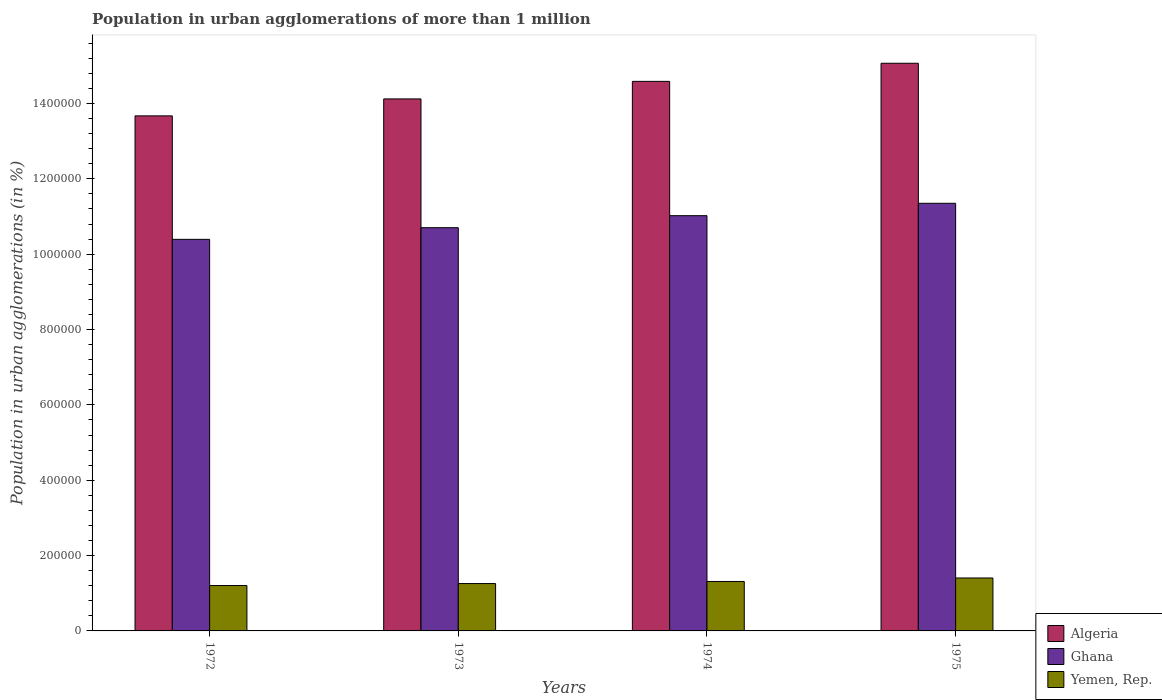How many different coloured bars are there?
Provide a short and direct response. 3. How many groups of bars are there?
Ensure brevity in your answer.  4. Are the number of bars per tick equal to the number of legend labels?
Your answer should be very brief. Yes. How many bars are there on the 3rd tick from the left?
Make the answer very short. 3. What is the population in urban agglomerations in Ghana in 1975?
Ensure brevity in your answer.  1.13e+06. Across all years, what is the maximum population in urban agglomerations in Ghana?
Give a very brief answer. 1.13e+06. Across all years, what is the minimum population in urban agglomerations in Yemen, Rep.?
Your response must be concise. 1.20e+05. In which year was the population in urban agglomerations in Yemen, Rep. maximum?
Keep it short and to the point. 1975. In which year was the population in urban agglomerations in Algeria minimum?
Give a very brief answer. 1972. What is the total population in urban agglomerations in Ghana in the graph?
Your answer should be very brief. 4.35e+06. What is the difference between the population in urban agglomerations in Ghana in 1972 and that in 1973?
Make the answer very short. -3.09e+04. What is the difference between the population in urban agglomerations in Ghana in 1975 and the population in urban agglomerations in Yemen, Rep. in 1972?
Offer a very short reply. 1.01e+06. What is the average population in urban agglomerations in Ghana per year?
Make the answer very short. 1.09e+06. In the year 1972, what is the difference between the population in urban agglomerations in Algeria and population in urban agglomerations in Yemen, Rep.?
Provide a short and direct response. 1.25e+06. In how many years, is the population in urban agglomerations in Yemen, Rep. greater than 160000 %?
Your answer should be compact. 0. What is the ratio of the population in urban agglomerations in Ghana in 1973 to that in 1974?
Your response must be concise. 0.97. Is the difference between the population in urban agglomerations in Algeria in 1973 and 1974 greater than the difference between the population in urban agglomerations in Yemen, Rep. in 1973 and 1974?
Your answer should be compact. No. What is the difference between the highest and the second highest population in urban agglomerations in Ghana?
Provide a succinct answer. 3.29e+04. What is the difference between the highest and the lowest population in urban agglomerations in Yemen, Rep.?
Your response must be concise. 2.01e+04. In how many years, is the population in urban agglomerations in Algeria greater than the average population in urban agglomerations in Algeria taken over all years?
Offer a very short reply. 2. Is the sum of the population in urban agglomerations in Algeria in 1972 and 1973 greater than the maximum population in urban agglomerations in Ghana across all years?
Provide a succinct answer. Yes. What does the 3rd bar from the left in 1974 represents?
Your answer should be very brief. Yemen, Rep. What does the 3rd bar from the right in 1973 represents?
Your answer should be very brief. Algeria. Is it the case that in every year, the sum of the population in urban agglomerations in Algeria and population in urban agglomerations in Ghana is greater than the population in urban agglomerations in Yemen, Rep.?
Your answer should be compact. Yes. Are all the bars in the graph horizontal?
Make the answer very short. No. How many years are there in the graph?
Your response must be concise. 4. Does the graph contain any zero values?
Give a very brief answer. No. Does the graph contain grids?
Offer a very short reply. No. How many legend labels are there?
Offer a very short reply. 3. What is the title of the graph?
Offer a terse response. Population in urban agglomerations of more than 1 million. Does "Mozambique" appear as one of the legend labels in the graph?
Your answer should be very brief. No. What is the label or title of the Y-axis?
Provide a succinct answer. Population in urban agglomerations (in %). What is the Population in urban agglomerations (in %) of Algeria in 1972?
Your response must be concise. 1.37e+06. What is the Population in urban agglomerations (in %) of Ghana in 1972?
Your answer should be very brief. 1.04e+06. What is the Population in urban agglomerations (in %) in Yemen, Rep. in 1972?
Provide a succinct answer. 1.20e+05. What is the Population in urban agglomerations (in %) of Algeria in 1973?
Keep it short and to the point. 1.41e+06. What is the Population in urban agglomerations (in %) in Ghana in 1973?
Your answer should be very brief. 1.07e+06. What is the Population in urban agglomerations (in %) in Yemen, Rep. in 1973?
Your response must be concise. 1.26e+05. What is the Population in urban agglomerations (in %) in Algeria in 1974?
Your response must be concise. 1.46e+06. What is the Population in urban agglomerations (in %) in Ghana in 1974?
Your answer should be compact. 1.10e+06. What is the Population in urban agglomerations (in %) in Yemen, Rep. in 1974?
Your response must be concise. 1.31e+05. What is the Population in urban agglomerations (in %) in Algeria in 1975?
Your answer should be compact. 1.51e+06. What is the Population in urban agglomerations (in %) in Ghana in 1975?
Offer a very short reply. 1.13e+06. What is the Population in urban agglomerations (in %) in Yemen, Rep. in 1975?
Your response must be concise. 1.41e+05. Across all years, what is the maximum Population in urban agglomerations (in %) of Algeria?
Ensure brevity in your answer.  1.51e+06. Across all years, what is the maximum Population in urban agglomerations (in %) in Ghana?
Give a very brief answer. 1.13e+06. Across all years, what is the maximum Population in urban agglomerations (in %) in Yemen, Rep.?
Your answer should be compact. 1.41e+05. Across all years, what is the minimum Population in urban agglomerations (in %) in Algeria?
Your answer should be very brief. 1.37e+06. Across all years, what is the minimum Population in urban agglomerations (in %) of Ghana?
Keep it short and to the point. 1.04e+06. Across all years, what is the minimum Population in urban agglomerations (in %) of Yemen, Rep.?
Make the answer very short. 1.20e+05. What is the total Population in urban agglomerations (in %) in Algeria in the graph?
Your answer should be compact. 5.74e+06. What is the total Population in urban agglomerations (in %) in Ghana in the graph?
Offer a very short reply. 4.35e+06. What is the total Population in urban agglomerations (in %) of Yemen, Rep. in the graph?
Give a very brief answer. 5.18e+05. What is the difference between the Population in urban agglomerations (in %) in Algeria in 1972 and that in 1973?
Your response must be concise. -4.50e+04. What is the difference between the Population in urban agglomerations (in %) in Ghana in 1972 and that in 1973?
Your answer should be compact. -3.09e+04. What is the difference between the Population in urban agglomerations (in %) of Yemen, Rep. in 1972 and that in 1973?
Provide a short and direct response. -5271. What is the difference between the Population in urban agglomerations (in %) in Algeria in 1972 and that in 1974?
Ensure brevity in your answer.  -9.15e+04. What is the difference between the Population in urban agglomerations (in %) in Ghana in 1972 and that in 1974?
Ensure brevity in your answer.  -6.28e+04. What is the difference between the Population in urban agglomerations (in %) in Yemen, Rep. in 1972 and that in 1974?
Your answer should be very brief. -1.08e+04. What is the difference between the Population in urban agglomerations (in %) in Algeria in 1972 and that in 1975?
Make the answer very short. -1.40e+05. What is the difference between the Population in urban agglomerations (in %) in Ghana in 1972 and that in 1975?
Give a very brief answer. -9.57e+04. What is the difference between the Population in urban agglomerations (in %) in Yemen, Rep. in 1972 and that in 1975?
Keep it short and to the point. -2.01e+04. What is the difference between the Population in urban agglomerations (in %) of Algeria in 1973 and that in 1974?
Your response must be concise. -4.65e+04. What is the difference between the Population in urban agglomerations (in %) of Ghana in 1973 and that in 1974?
Offer a very short reply. -3.19e+04. What is the difference between the Population in urban agglomerations (in %) in Yemen, Rep. in 1973 and that in 1974?
Your response must be concise. -5510. What is the difference between the Population in urban agglomerations (in %) in Algeria in 1973 and that in 1975?
Offer a very short reply. -9.46e+04. What is the difference between the Population in urban agglomerations (in %) in Ghana in 1973 and that in 1975?
Your response must be concise. -6.48e+04. What is the difference between the Population in urban agglomerations (in %) in Yemen, Rep. in 1973 and that in 1975?
Your answer should be compact. -1.48e+04. What is the difference between the Population in urban agglomerations (in %) of Algeria in 1974 and that in 1975?
Keep it short and to the point. -4.81e+04. What is the difference between the Population in urban agglomerations (in %) in Ghana in 1974 and that in 1975?
Your answer should be compact. -3.29e+04. What is the difference between the Population in urban agglomerations (in %) in Yemen, Rep. in 1974 and that in 1975?
Provide a succinct answer. -9297. What is the difference between the Population in urban agglomerations (in %) in Algeria in 1972 and the Population in urban agglomerations (in %) in Ghana in 1973?
Your answer should be very brief. 2.97e+05. What is the difference between the Population in urban agglomerations (in %) in Algeria in 1972 and the Population in urban agglomerations (in %) in Yemen, Rep. in 1973?
Offer a very short reply. 1.24e+06. What is the difference between the Population in urban agglomerations (in %) of Ghana in 1972 and the Population in urban agglomerations (in %) of Yemen, Rep. in 1973?
Offer a terse response. 9.14e+05. What is the difference between the Population in urban agglomerations (in %) of Algeria in 1972 and the Population in urban agglomerations (in %) of Ghana in 1974?
Keep it short and to the point. 2.65e+05. What is the difference between the Population in urban agglomerations (in %) of Algeria in 1972 and the Population in urban agglomerations (in %) of Yemen, Rep. in 1974?
Ensure brevity in your answer.  1.24e+06. What is the difference between the Population in urban agglomerations (in %) in Ghana in 1972 and the Population in urban agglomerations (in %) in Yemen, Rep. in 1974?
Keep it short and to the point. 9.08e+05. What is the difference between the Population in urban agglomerations (in %) of Algeria in 1972 and the Population in urban agglomerations (in %) of Ghana in 1975?
Offer a very short reply. 2.32e+05. What is the difference between the Population in urban agglomerations (in %) of Algeria in 1972 and the Population in urban agglomerations (in %) of Yemen, Rep. in 1975?
Your answer should be very brief. 1.23e+06. What is the difference between the Population in urban agglomerations (in %) of Ghana in 1972 and the Population in urban agglomerations (in %) of Yemen, Rep. in 1975?
Give a very brief answer. 8.99e+05. What is the difference between the Population in urban agglomerations (in %) of Algeria in 1973 and the Population in urban agglomerations (in %) of Ghana in 1974?
Your answer should be very brief. 3.10e+05. What is the difference between the Population in urban agglomerations (in %) of Algeria in 1973 and the Population in urban agglomerations (in %) of Yemen, Rep. in 1974?
Your response must be concise. 1.28e+06. What is the difference between the Population in urban agglomerations (in %) of Ghana in 1973 and the Population in urban agglomerations (in %) of Yemen, Rep. in 1974?
Ensure brevity in your answer.  9.39e+05. What is the difference between the Population in urban agglomerations (in %) of Algeria in 1973 and the Population in urban agglomerations (in %) of Ghana in 1975?
Ensure brevity in your answer.  2.77e+05. What is the difference between the Population in urban agglomerations (in %) in Algeria in 1973 and the Population in urban agglomerations (in %) in Yemen, Rep. in 1975?
Your answer should be compact. 1.27e+06. What is the difference between the Population in urban agglomerations (in %) in Ghana in 1973 and the Population in urban agglomerations (in %) in Yemen, Rep. in 1975?
Provide a succinct answer. 9.30e+05. What is the difference between the Population in urban agglomerations (in %) of Algeria in 1974 and the Population in urban agglomerations (in %) of Ghana in 1975?
Make the answer very short. 3.24e+05. What is the difference between the Population in urban agglomerations (in %) in Algeria in 1974 and the Population in urban agglomerations (in %) in Yemen, Rep. in 1975?
Offer a terse response. 1.32e+06. What is the difference between the Population in urban agglomerations (in %) in Ghana in 1974 and the Population in urban agglomerations (in %) in Yemen, Rep. in 1975?
Give a very brief answer. 9.62e+05. What is the average Population in urban agglomerations (in %) in Algeria per year?
Provide a succinct answer. 1.44e+06. What is the average Population in urban agglomerations (in %) of Ghana per year?
Your answer should be very brief. 1.09e+06. What is the average Population in urban agglomerations (in %) of Yemen, Rep. per year?
Provide a short and direct response. 1.29e+05. In the year 1972, what is the difference between the Population in urban agglomerations (in %) of Algeria and Population in urban agglomerations (in %) of Ghana?
Give a very brief answer. 3.28e+05. In the year 1972, what is the difference between the Population in urban agglomerations (in %) of Algeria and Population in urban agglomerations (in %) of Yemen, Rep.?
Provide a short and direct response. 1.25e+06. In the year 1972, what is the difference between the Population in urban agglomerations (in %) in Ghana and Population in urban agglomerations (in %) in Yemen, Rep.?
Provide a short and direct response. 9.19e+05. In the year 1973, what is the difference between the Population in urban agglomerations (in %) in Algeria and Population in urban agglomerations (in %) in Ghana?
Provide a succinct answer. 3.42e+05. In the year 1973, what is the difference between the Population in urban agglomerations (in %) in Algeria and Population in urban agglomerations (in %) in Yemen, Rep.?
Make the answer very short. 1.29e+06. In the year 1973, what is the difference between the Population in urban agglomerations (in %) in Ghana and Population in urban agglomerations (in %) in Yemen, Rep.?
Ensure brevity in your answer.  9.44e+05. In the year 1974, what is the difference between the Population in urban agglomerations (in %) in Algeria and Population in urban agglomerations (in %) in Ghana?
Keep it short and to the point. 3.56e+05. In the year 1974, what is the difference between the Population in urban agglomerations (in %) in Algeria and Population in urban agglomerations (in %) in Yemen, Rep.?
Provide a succinct answer. 1.33e+06. In the year 1974, what is the difference between the Population in urban agglomerations (in %) of Ghana and Population in urban agglomerations (in %) of Yemen, Rep.?
Your answer should be very brief. 9.71e+05. In the year 1975, what is the difference between the Population in urban agglomerations (in %) in Algeria and Population in urban agglomerations (in %) in Ghana?
Ensure brevity in your answer.  3.72e+05. In the year 1975, what is the difference between the Population in urban agglomerations (in %) of Algeria and Population in urban agglomerations (in %) of Yemen, Rep.?
Provide a succinct answer. 1.37e+06. In the year 1975, what is the difference between the Population in urban agglomerations (in %) in Ghana and Population in urban agglomerations (in %) in Yemen, Rep.?
Provide a succinct answer. 9.94e+05. What is the ratio of the Population in urban agglomerations (in %) in Algeria in 1972 to that in 1973?
Your answer should be very brief. 0.97. What is the ratio of the Population in urban agglomerations (in %) in Ghana in 1972 to that in 1973?
Make the answer very short. 0.97. What is the ratio of the Population in urban agglomerations (in %) in Yemen, Rep. in 1972 to that in 1973?
Offer a very short reply. 0.96. What is the ratio of the Population in urban agglomerations (in %) in Algeria in 1972 to that in 1974?
Make the answer very short. 0.94. What is the ratio of the Population in urban agglomerations (in %) in Ghana in 1972 to that in 1974?
Give a very brief answer. 0.94. What is the ratio of the Population in urban agglomerations (in %) in Yemen, Rep. in 1972 to that in 1974?
Provide a succinct answer. 0.92. What is the ratio of the Population in urban agglomerations (in %) in Algeria in 1972 to that in 1975?
Offer a very short reply. 0.91. What is the ratio of the Population in urban agglomerations (in %) in Ghana in 1972 to that in 1975?
Your response must be concise. 0.92. What is the ratio of the Population in urban agglomerations (in %) of Algeria in 1973 to that in 1974?
Ensure brevity in your answer.  0.97. What is the ratio of the Population in urban agglomerations (in %) of Ghana in 1973 to that in 1974?
Keep it short and to the point. 0.97. What is the ratio of the Population in urban agglomerations (in %) in Yemen, Rep. in 1973 to that in 1974?
Keep it short and to the point. 0.96. What is the ratio of the Population in urban agglomerations (in %) of Algeria in 1973 to that in 1975?
Offer a terse response. 0.94. What is the ratio of the Population in urban agglomerations (in %) in Ghana in 1973 to that in 1975?
Provide a short and direct response. 0.94. What is the ratio of the Population in urban agglomerations (in %) of Yemen, Rep. in 1973 to that in 1975?
Provide a succinct answer. 0.89. What is the ratio of the Population in urban agglomerations (in %) in Algeria in 1974 to that in 1975?
Provide a succinct answer. 0.97. What is the ratio of the Population in urban agglomerations (in %) in Yemen, Rep. in 1974 to that in 1975?
Keep it short and to the point. 0.93. What is the difference between the highest and the second highest Population in urban agglomerations (in %) of Algeria?
Keep it short and to the point. 4.81e+04. What is the difference between the highest and the second highest Population in urban agglomerations (in %) in Ghana?
Provide a succinct answer. 3.29e+04. What is the difference between the highest and the second highest Population in urban agglomerations (in %) of Yemen, Rep.?
Provide a succinct answer. 9297. What is the difference between the highest and the lowest Population in urban agglomerations (in %) of Algeria?
Keep it short and to the point. 1.40e+05. What is the difference between the highest and the lowest Population in urban agglomerations (in %) of Ghana?
Your response must be concise. 9.57e+04. What is the difference between the highest and the lowest Population in urban agglomerations (in %) in Yemen, Rep.?
Ensure brevity in your answer.  2.01e+04. 